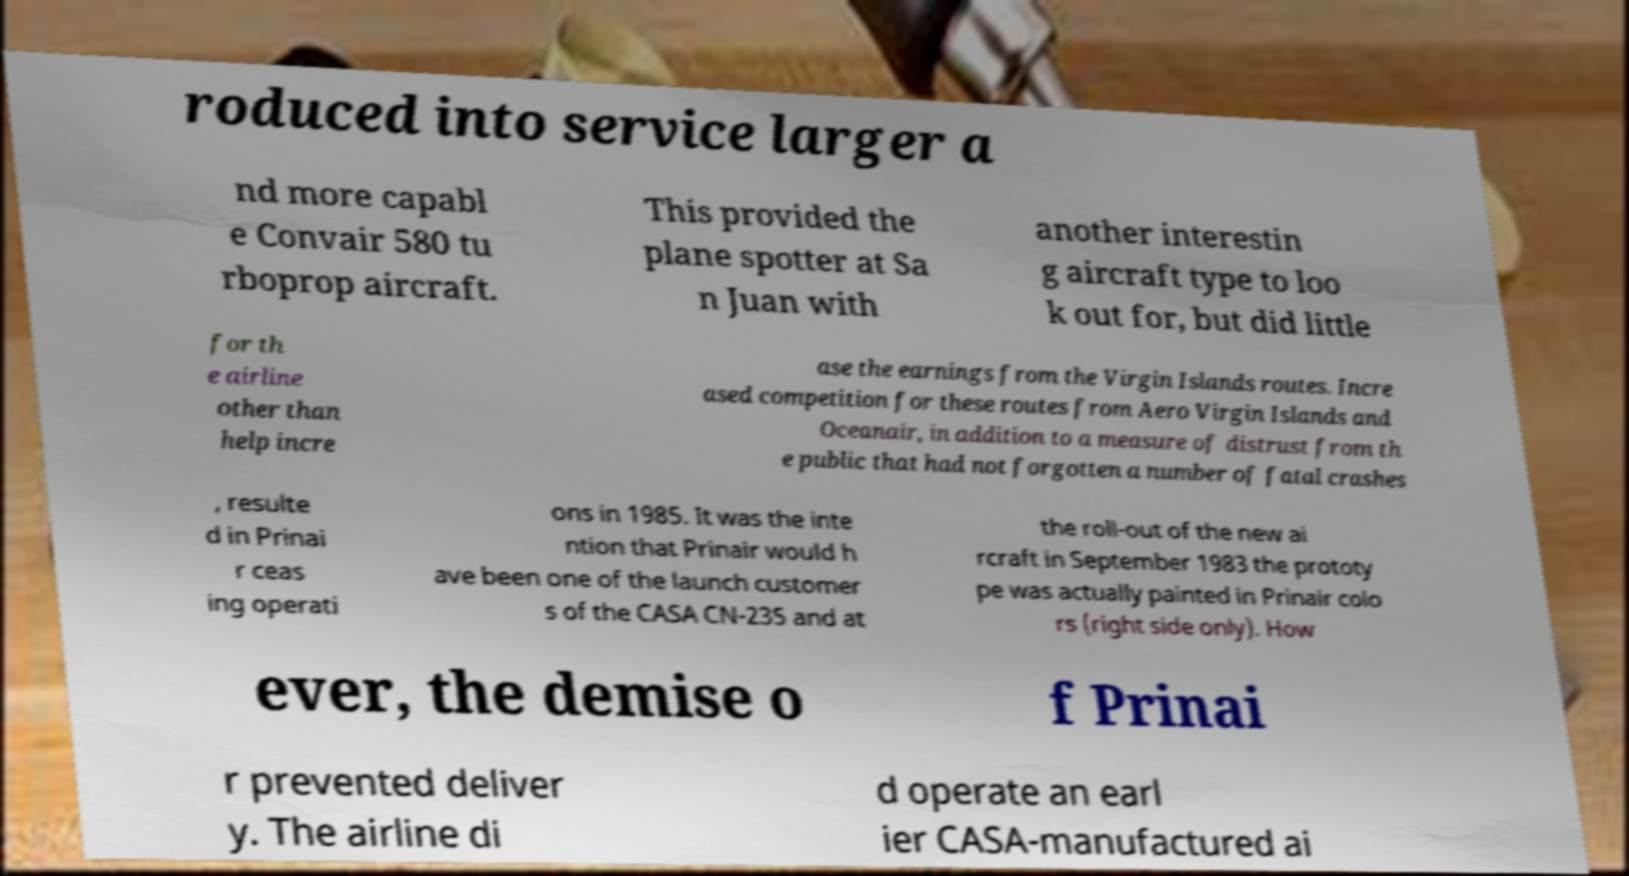Please identify and transcribe the text found in this image. roduced into service larger a nd more capabl e Convair 580 tu rboprop aircraft. This provided the plane spotter at Sa n Juan with another interestin g aircraft type to loo k out for, but did little for th e airline other than help incre ase the earnings from the Virgin Islands routes. Incre ased competition for these routes from Aero Virgin Islands and Oceanair, in addition to a measure of distrust from th e public that had not forgotten a number of fatal crashes , resulte d in Prinai r ceas ing operati ons in 1985. It was the inte ntion that Prinair would h ave been one of the launch customer s of the CASA CN-235 and at the roll-out of the new ai rcraft in September 1983 the prototy pe was actually painted in Prinair colo rs (right side only). How ever, the demise o f Prinai r prevented deliver y. The airline di d operate an earl ier CASA-manufactured ai 